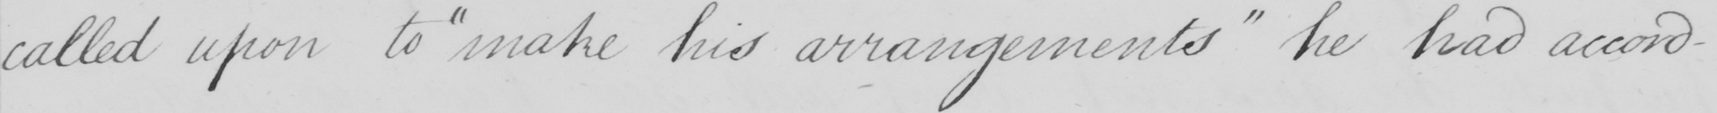Can you tell me what this handwritten text says? called upon to  " make his arrangements "  he had accord- 